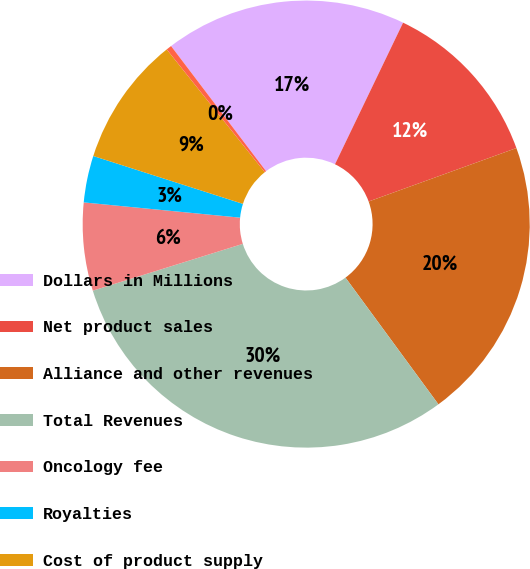Convert chart to OTSL. <chart><loc_0><loc_0><loc_500><loc_500><pie_chart><fcel>Dollars in Millions<fcel>Net product sales<fcel>Alliance and other revenues<fcel>Total Revenues<fcel>Oncology fee<fcel>Royalties<fcel>Cost of product supply<fcel>Cost reimbursements to/(from)<nl><fcel>17.47%<fcel>12.34%<fcel>20.45%<fcel>30.26%<fcel>6.36%<fcel>3.38%<fcel>9.35%<fcel>0.39%<nl></chart> 